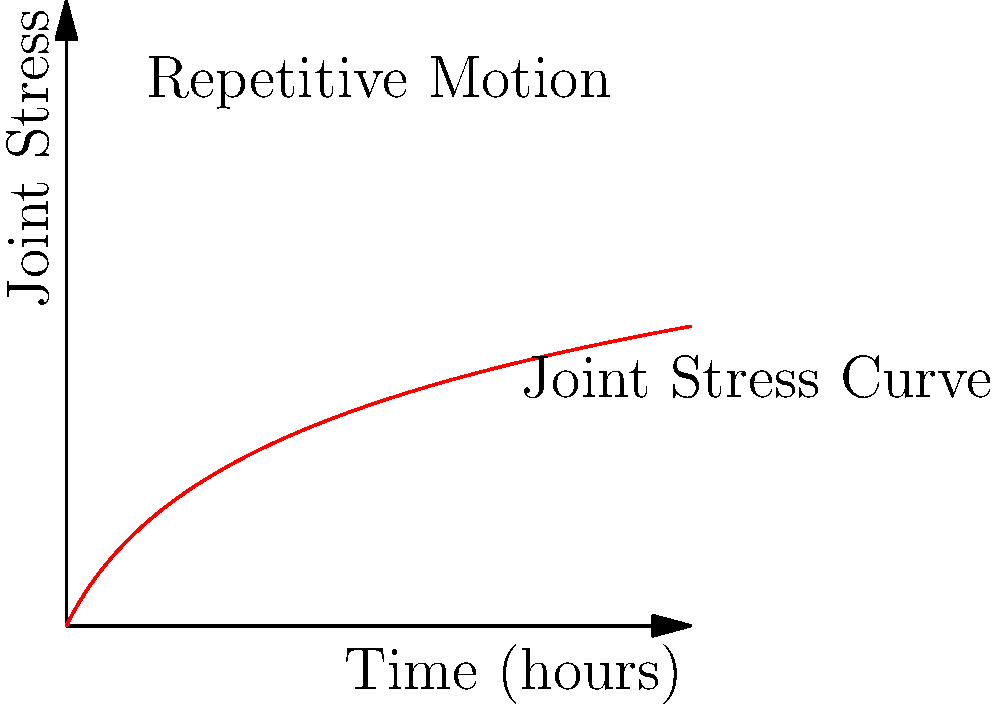Consider the graph showing the relationship between time spent on detailed artistic work and joint stress. If you typically work for 8 hours a day, what preventive measure would be most effective in reducing the cumulative stress on your joints? To answer this question, let's analyze the graph and consider the biomechanics of repetitive motions:

1. The graph shows a logarithmic relationship between time spent working and joint stress.
2. As time increases, joint stress increases rapidly at first, then the rate of increase slows down.
3. However, the total stress continues to accumulate over time.
4. For an 8-hour workday, the joint stress level would be quite high.
5. To reduce cumulative stress, we need to interrupt this continuous accumulation.
6. Taking regular breaks would effectively "reset" the stress curve periodically.
7. This would prevent reaching the higher stress levels shown on the right side of the graph.
8. Other measures like ergonomic tools or stretching are helpful but don't directly address the time-stress relationship shown.

Therefore, the most effective measure to reduce cumulative joint stress would be to take regular breaks throughout the 8-hour workday.
Answer: Take regular breaks 